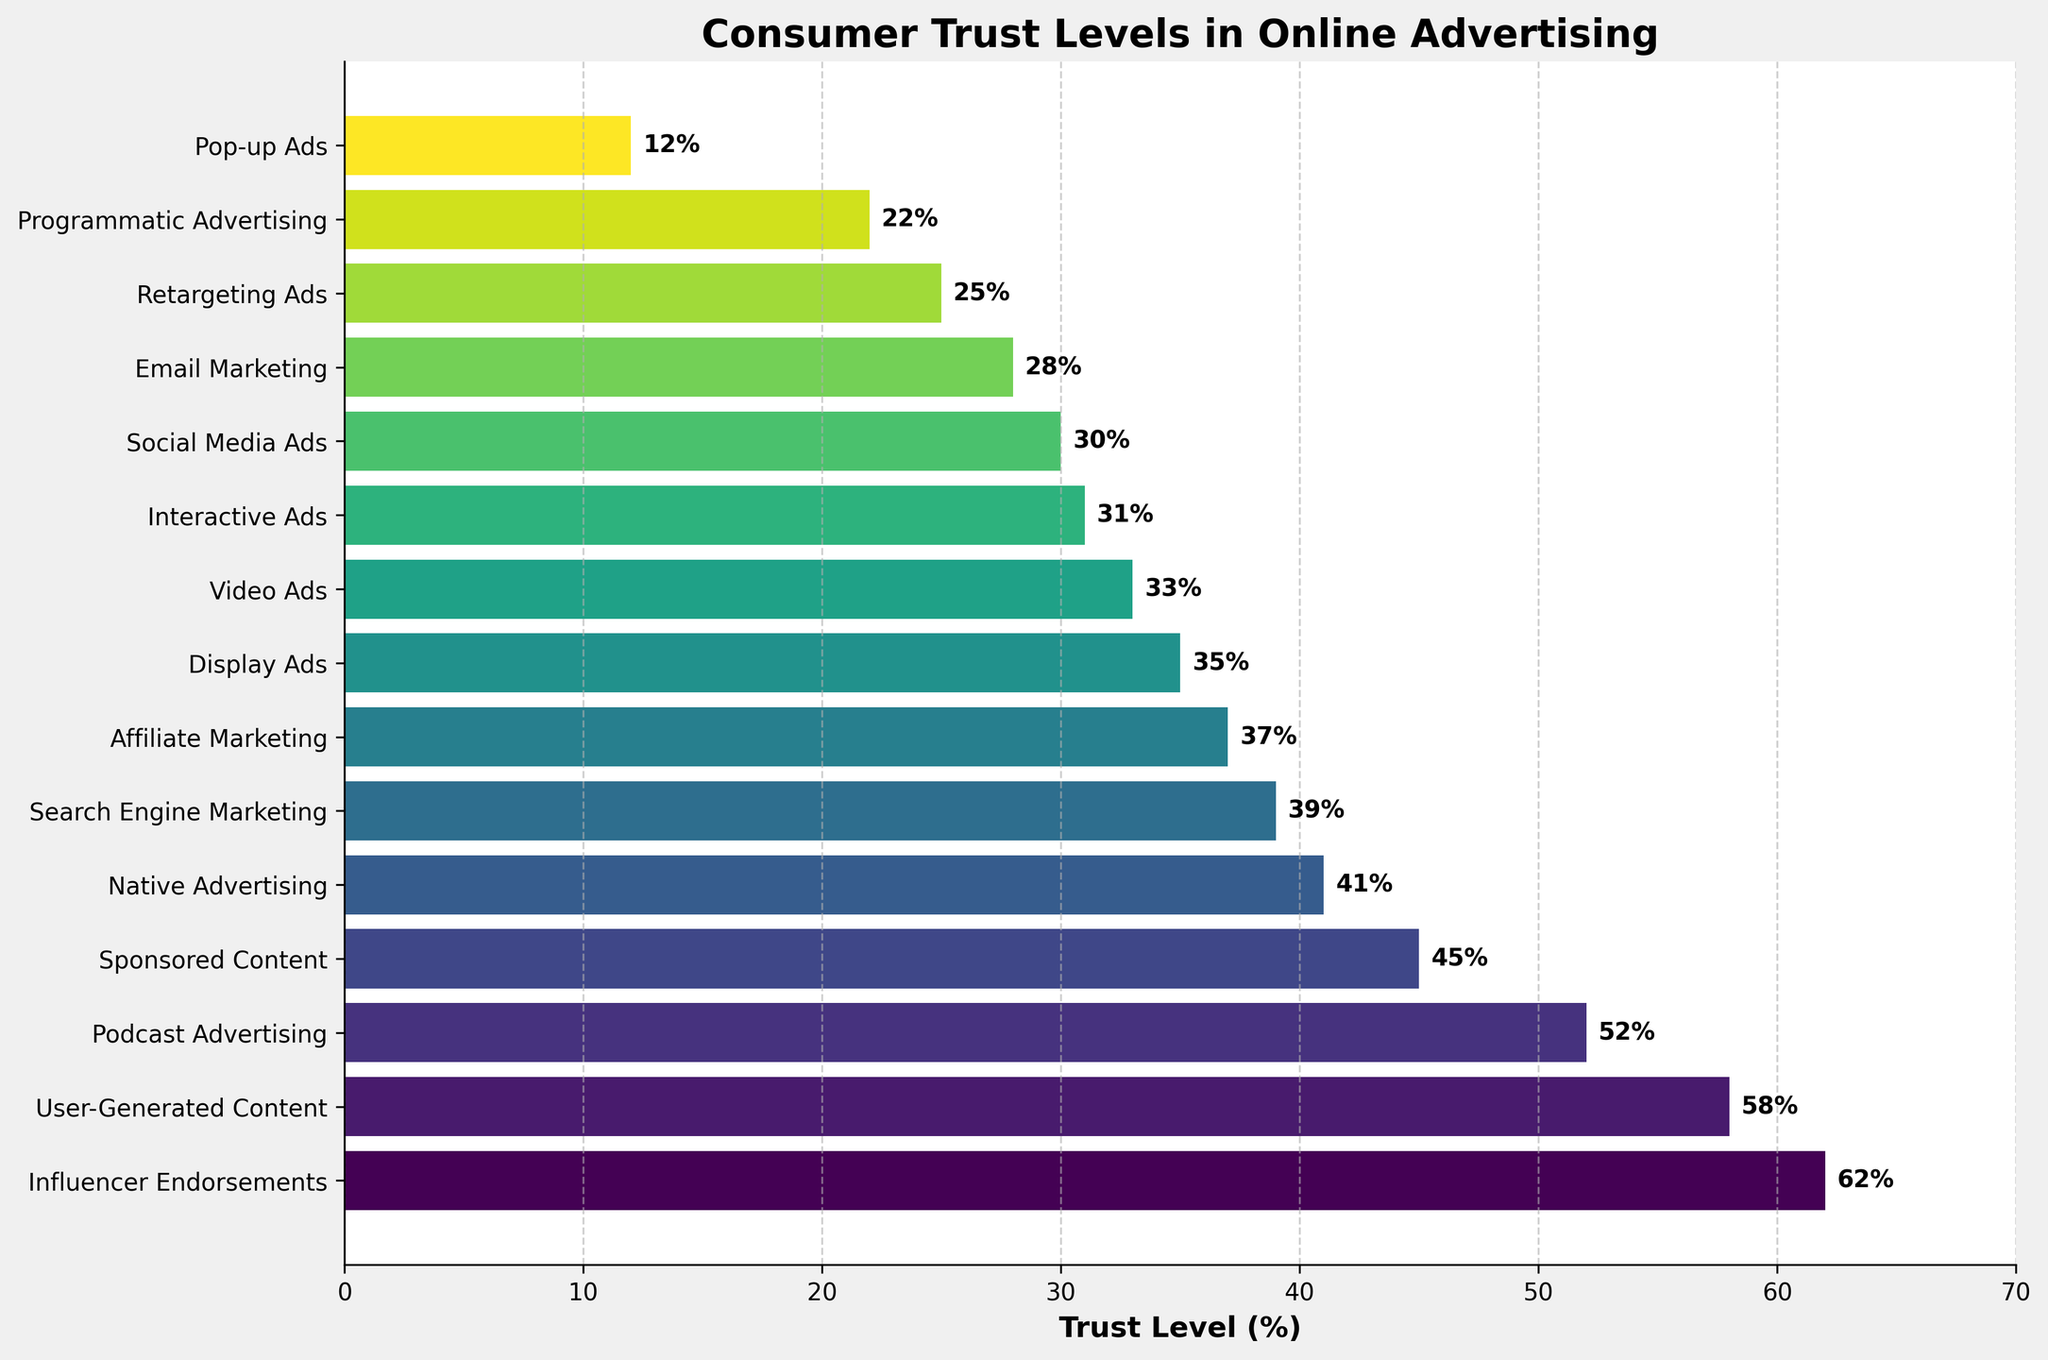Which type of ad has the highest trust level? The ad type with the highest trust level is at the top of the bar chart, indicating it has the highest value on the x-axis.
Answer: Influencer Endorsements Which ad types have trust levels greater than 50%? Ad types with trust levels greater than 50% are those whose bars extend beyond the 50% mark on the x-axis. From the chart, these are the top few bars.
Answer: Influencer Endorsements, User-Generated Content, Podcast Advertising Which ad type has the lowest trust level? The ad type with the lowest trust level is at the bottom of the bar chart, indicating it has the lowest value on the x-axis.
Answer: Pop-up Ads How much more trusted are Influencer Endorsements compared to Social Media Ads? To find how much more trusted Influencer Endorsements are compared to Social Media Ads, subtract the trust level of Social Media Ads from that of Influencer Endorsements. (62% - 30%)
Answer: 32% What's the average trust level of Interactive Ads, Programmatic Advertising, and Retargeting Ads? Add the trust levels of the three ad types and then divide by the number of ad types to find the average. (31% + 22% + 25%) / 3 = 78% / 3
Answer: 26% Which ad types fall in the 40% to 50% trust level range? Ad types in the 40% to 50% range have bars that end between these values on the x-axis. The identified types are below Podcast Advertising and above User-Generated Content.
Answer: Sponsored Content, Native Advertising Between Display Ads and Video Ads, which is more trusted and by how much? By comparing the lengths of the bars for Display Ads and Video Ads, find the difference in their trust levels. (35% - 33%)
Answer: Display Ads by 2% What's the median trust level for all the ad types? Order all trust levels and find the middle value. The sorted list of trust levels is [12%, 22%, 25%, 28%, 30%, 31%, 33%, 35%, 37%, 39%, 41%, 45%, 52%, 58%, 62%]. The middle value is the average of the 8th and 9th values. (35% + 37%) / 2
Answer: 36% How much does trust in Native Advertising differ from trust in Sponsored Content? Subtract the trust level of Native Advertising from that of Sponsored Content. (45% - 41%)
Answer: 4% If we group ad types into two categories: those above 40% trust and those 40% or below, what's the average trust level for each group? Calculate the average of ad types. Above 40%: (62% + 58% + 52% + 45% + 41%) / 5 = 258% / 5 = 51.6%. 40% or below: (12% + 22% + 25% + 28% + 30% + 31% + 33% + 35% + 37% + 39%) / 10 = 292% / 10 = 29.2%
Answer: Above 40%: 51.6%, 40% or below: 29.2% 